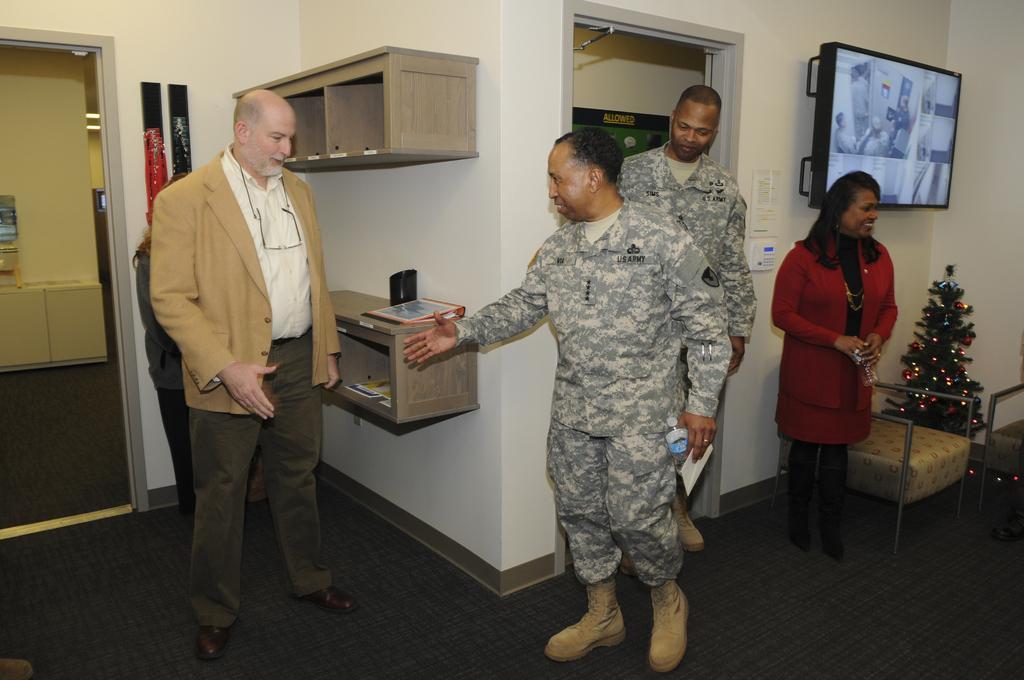In one or two sentences, can you explain what this image depicts? IN this picture we can see four people, Christmas tree, some chairs and a desk to the wall. 